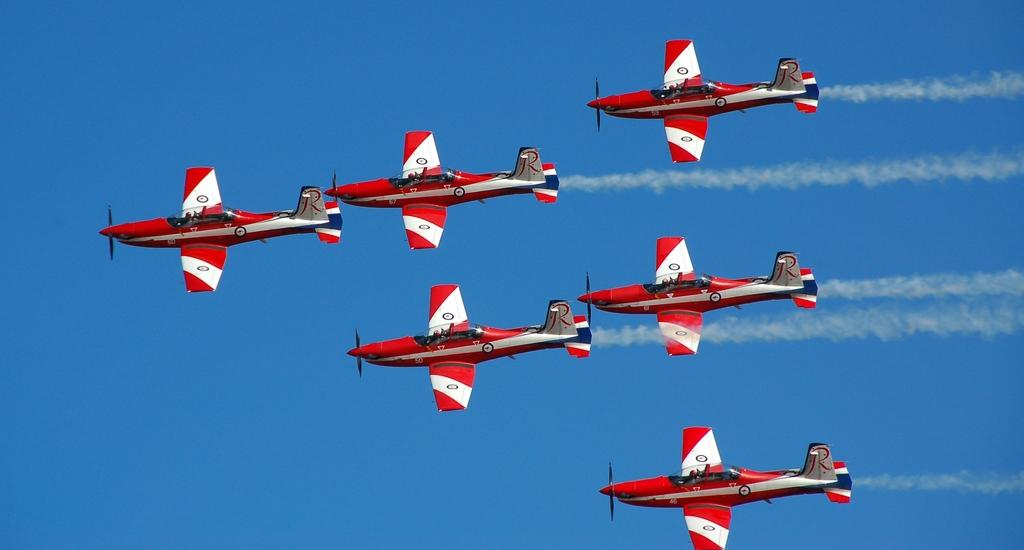What is happening in the sky in the image? There are planes in the air in the image. What can be seen behind the planes in the sky? The sky is visible behind the planes in the image. How many flowers are present in the image? There are no flowers visible in the image; it features planes in the air and the sky. What historical event is depicted in the image? There is no historical event depicted in the image; it simply shows planes in the air and the sky. 